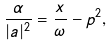<formula> <loc_0><loc_0><loc_500><loc_500>\frac { \alpha } { | a | ^ { 2 } } = \frac { x } { \omega } - p ^ { 2 } ,</formula> 